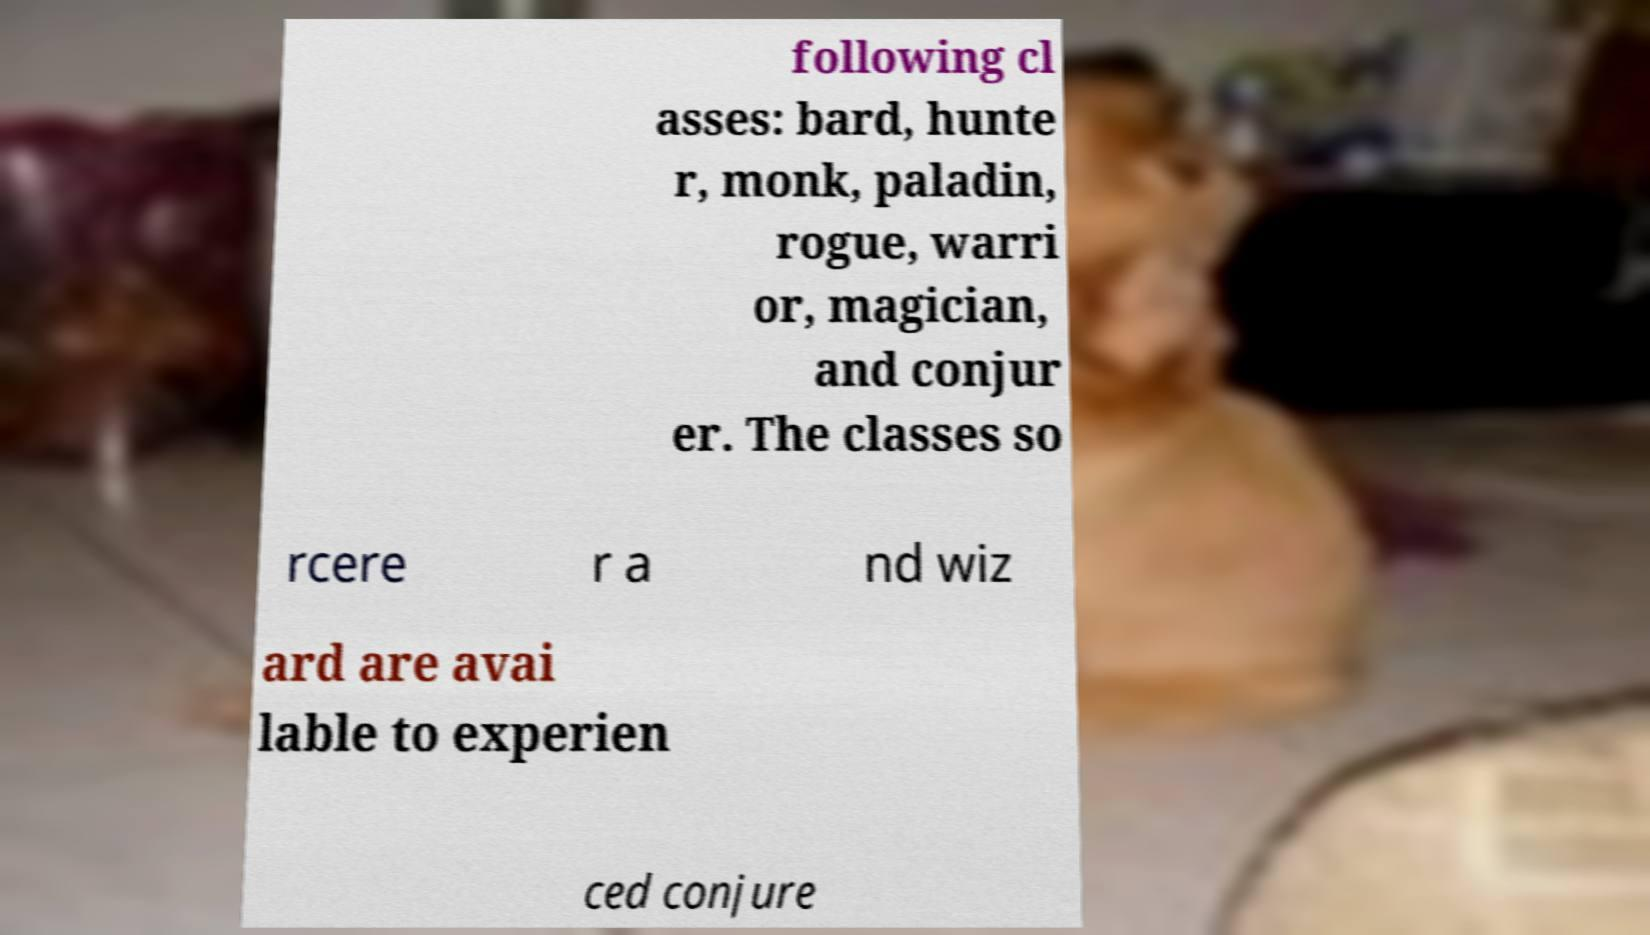Could you assist in decoding the text presented in this image and type it out clearly? following cl asses: bard, hunte r, monk, paladin, rogue, warri or, magician, and conjur er. The classes so rcere r a nd wiz ard are avai lable to experien ced conjure 